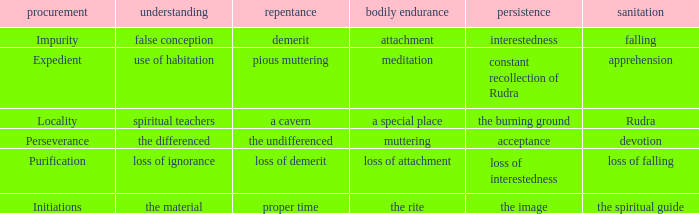 what's the constancy where permanence of the body is meditation Constant recollection of rudra. 